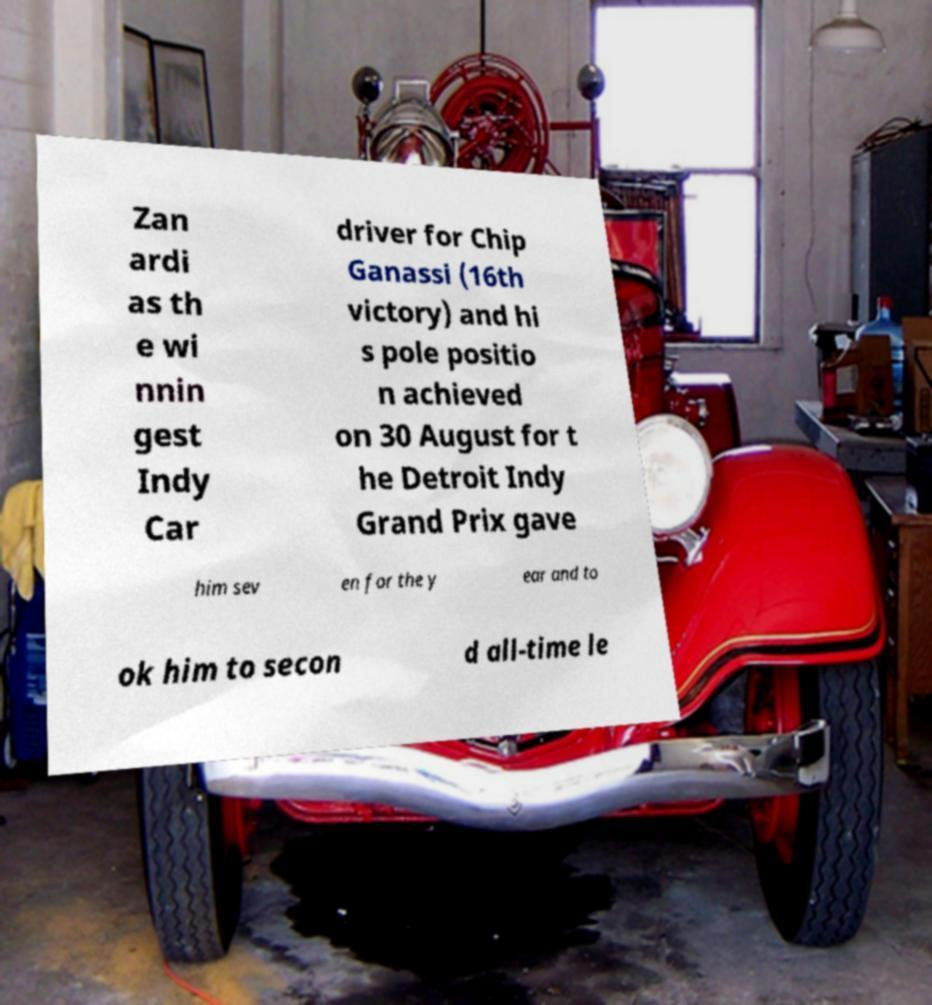Could you extract and type out the text from this image? Zan ardi as th e wi nnin gest Indy Car driver for Chip Ganassi (16th victory) and hi s pole positio n achieved on 30 August for t he Detroit Indy Grand Prix gave him sev en for the y ear and to ok him to secon d all-time le 